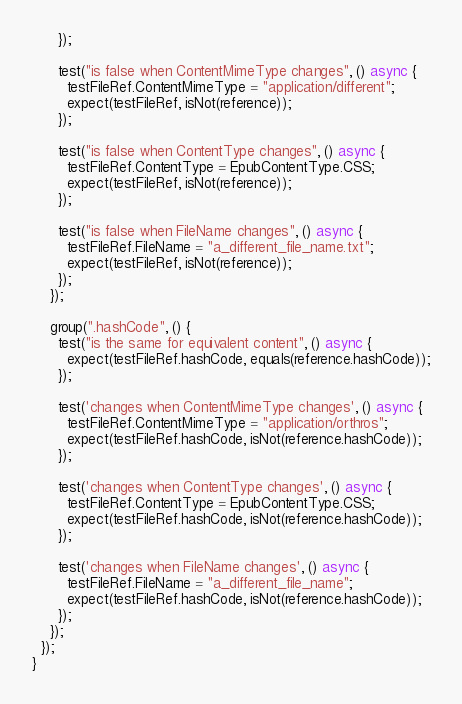<code> <loc_0><loc_0><loc_500><loc_500><_Dart_>      });

      test("is false when ContentMimeType changes", () async {
        testFileRef.ContentMimeType = "application/different";
        expect(testFileRef, isNot(reference));
      });

      test("is false when ContentType changes", () async {
        testFileRef.ContentType = EpubContentType.CSS;
        expect(testFileRef, isNot(reference));
      });

      test("is false when FileName changes", () async {
        testFileRef.FileName = "a_different_file_name.txt";
        expect(testFileRef, isNot(reference));
      });
    });

    group(".hashCode", () {
      test("is the same for equivalent content", () async {
        expect(testFileRef.hashCode, equals(reference.hashCode));
      });

      test('changes when ContentMimeType changes', () async {
        testFileRef.ContentMimeType = "application/orthros";
        expect(testFileRef.hashCode, isNot(reference.hashCode));
      });

      test('changes when ContentType changes', () async {
        testFileRef.ContentType = EpubContentType.CSS;
        expect(testFileRef.hashCode, isNot(reference.hashCode));
      });

      test('changes when FileName changes', () async {
        testFileRef.FileName = "a_different_file_name";
        expect(testFileRef.hashCode, isNot(reference.hashCode));
      });
    });
  });
}
</code> 